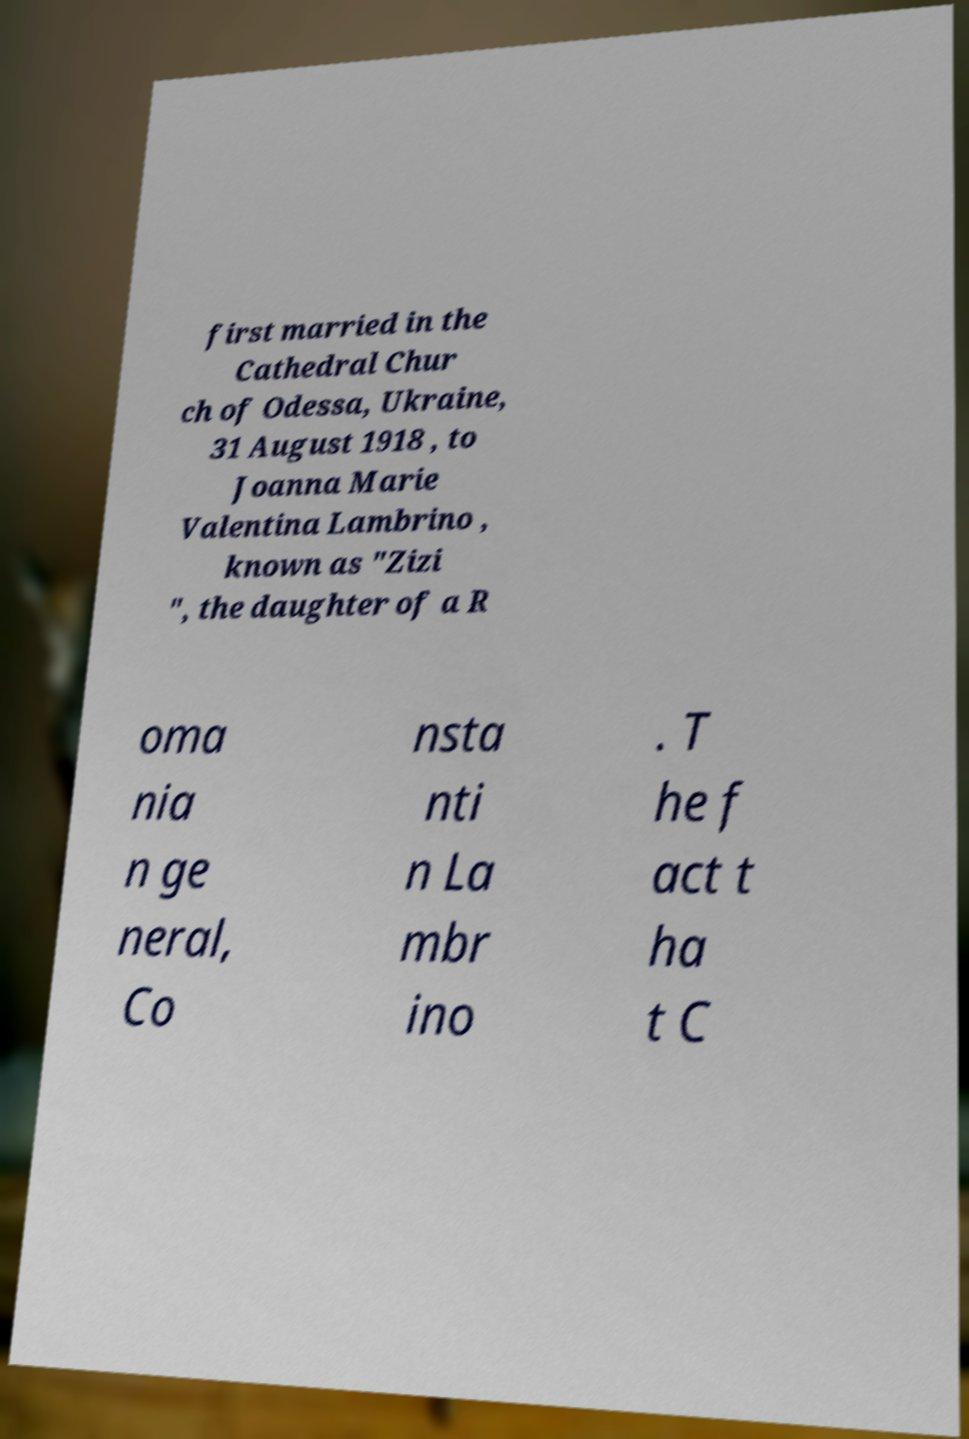Please identify and transcribe the text found in this image. first married in the Cathedral Chur ch of Odessa, Ukraine, 31 August 1918 , to Joanna Marie Valentina Lambrino , known as "Zizi ", the daughter of a R oma nia n ge neral, Co nsta nti n La mbr ino . T he f act t ha t C 